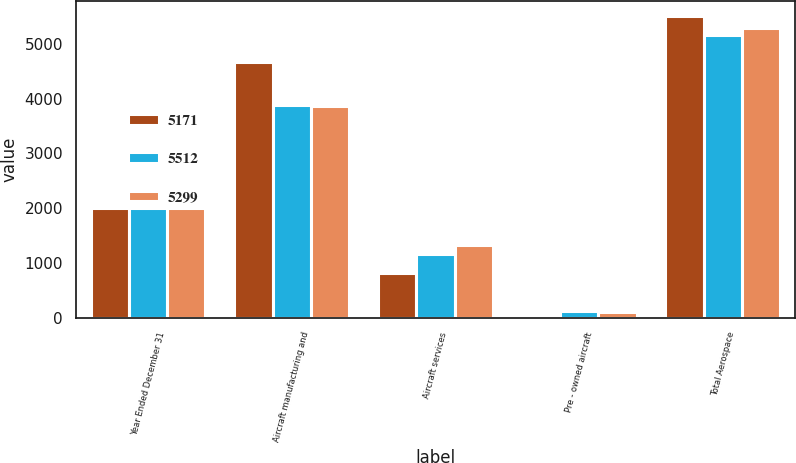Convert chart to OTSL. <chart><loc_0><loc_0><loc_500><loc_500><stacked_bar_chart><ecel><fcel>Year Ended December 31<fcel>Aircraft manufacturing and<fcel>Aircraft services<fcel>Pre - owned aircraft<fcel>Total Aerospace<nl><fcel>5171<fcel>2008<fcel>4678<fcel>816<fcel>18<fcel>5512<nl><fcel>5512<fcel>2009<fcel>3893<fcel>1154<fcel>124<fcel>5171<nl><fcel>5299<fcel>2010<fcel>3869<fcel>1323<fcel>107<fcel>5299<nl></chart> 